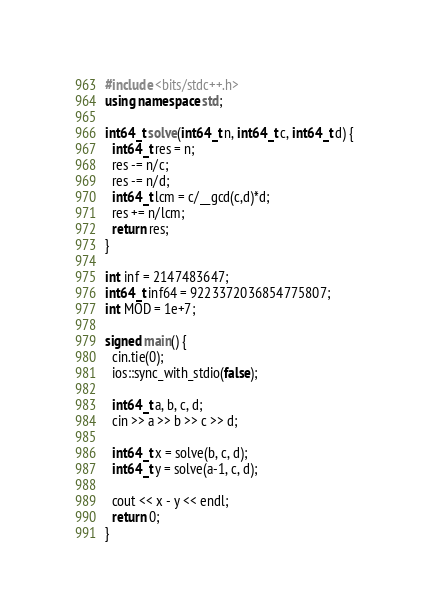<code> <loc_0><loc_0><loc_500><loc_500><_C++_>#include <bits/stdc++.h>
using namespace std;

int64_t solve(int64_t n, int64_t c, int64_t d) {
  int64_t res = n;
  res -= n/c;
  res -= n/d;
  int64_t lcm = c/__gcd(c,d)*d;
  res += n/lcm;
  return res;
}

int inf = 2147483647;
int64_t inf64 = 9223372036854775807;
int MOD = 1e+7;

signed main() {
  cin.tie(0);
  ios::sync_with_stdio(false);

  int64_t a, b, c, d;
  cin >> a >> b >> c >> d;

  int64_t x = solve(b, c, d);
  int64_t y = solve(a-1, c, d);

  cout << x - y << endl;
  return 0;
}</code> 